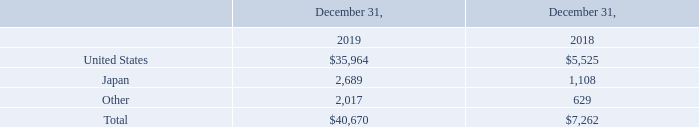Geographic Information
The following table is a summary of our long-lived assets which include property and equipment, net and right of use assets based on the physical location of the assets (in thousands):
What kind of asset data is described in the table? Long-lived assets which include property and equipment, net and right of use assets based on the physical location of the assets. What is the units used to describe the data in the table? Thousands. Which countries' data have been singled out in the table? United states, japan. What is the total amount of long-lived asset in Japan in both 2018 and 2019?
Answer scale should be: thousand. 2,689+1,108
Answer: 3797. What is the percentage change in value between long-lived assets in the U.S. in 2018 and 2019?
Answer scale should be: percent. ($35,964 - $5,525)/$5,525 
Answer: 550.93. What is the total value of long-lived assets in the U.S. and Japan in 2019?
Answer scale should be: thousand. $35,964+2,689
Answer: 38653. 